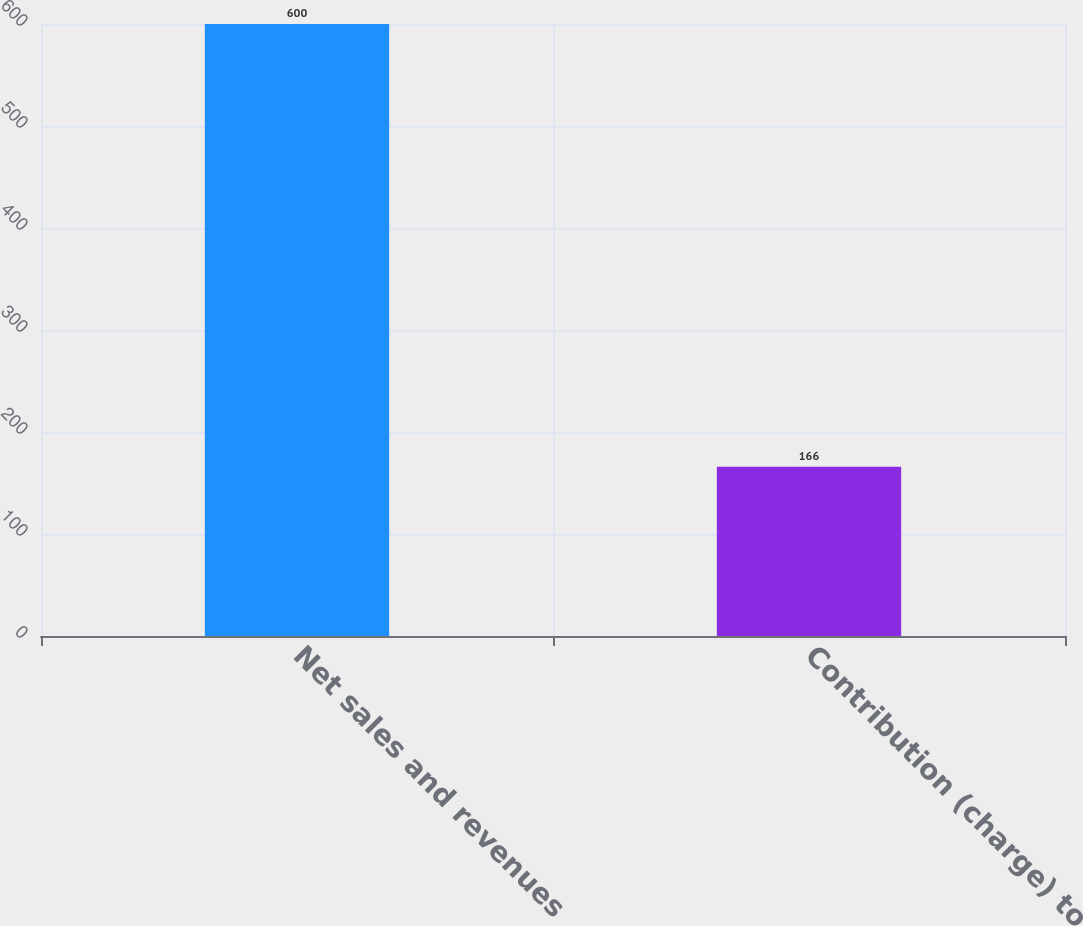Convert chart. <chart><loc_0><loc_0><loc_500><loc_500><bar_chart><fcel>Net sales and revenues<fcel>Contribution (charge) to<nl><fcel>600<fcel>166<nl></chart> 